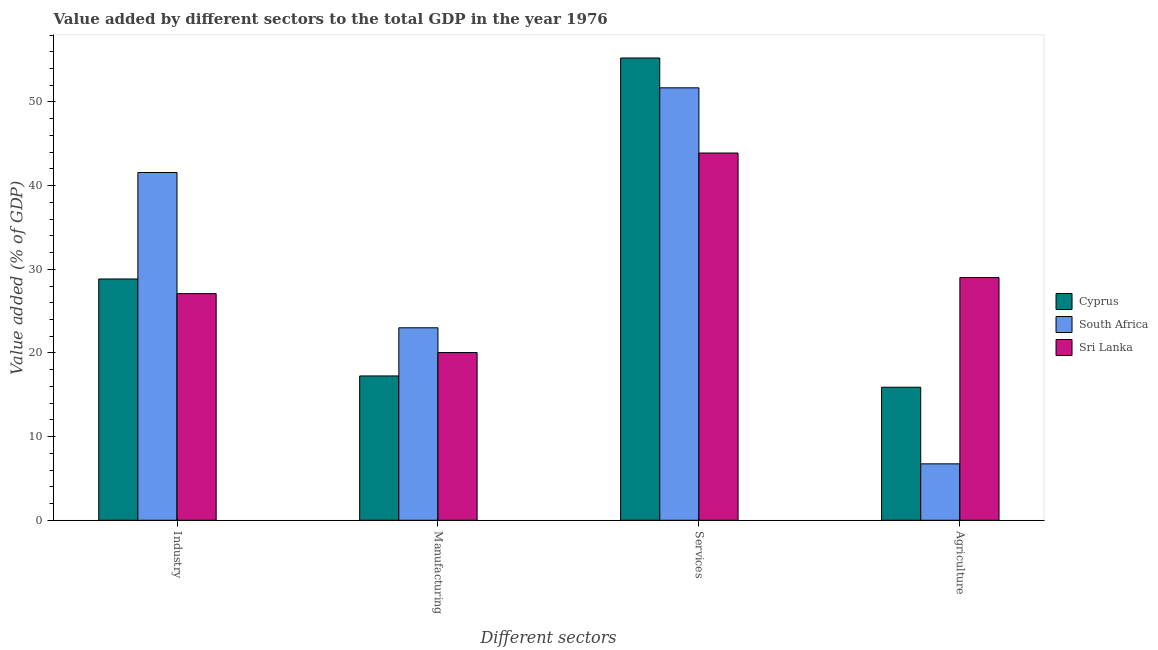Are the number of bars per tick equal to the number of legend labels?
Your response must be concise. Yes. How many bars are there on the 3rd tick from the left?
Ensure brevity in your answer.  3. How many bars are there on the 2nd tick from the right?
Your answer should be very brief. 3. What is the label of the 1st group of bars from the left?
Your answer should be compact. Industry. What is the value added by manufacturing sector in South Africa?
Make the answer very short. 23.01. Across all countries, what is the maximum value added by manufacturing sector?
Your answer should be very brief. 23.01. Across all countries, what is the minimum value added by services sector?
Offer a terse response. 43.9. In which country was the value added by industrial sector maximum?
Your answer should be compact. South Africa. In which country was the value added by manufacturing sector minimum?
Offer a very short reply. Cyprus. What is the total value added by agricultural sector in the graph?
Your answer should be compact. 51.66. What is the difference between the value added by services sector in Cyprus and that in South Africa?
Give a very brief answer. 3.57. What is the difference between the value added by agricultural sector in Cyprus and the value added by manufacturing sector in South Africa?
Provide a short and direct response. -7.1. What is the average value added by industrial sector per country?
Provide a short and direct response. 32.5. What is the difference between the value added by industrial sector and value added by services sector in Cyprus?
Keep it short and to the point. -26.42. What is the ratio of the value added by industrial sector in Sri Lanka to that in South Africa?
Offer a terse response. 0.65. What is the difference between the highest and the second highest value added by manufacturing sector?
Provide a succinct answer. 2.96. What is the difference between the highest and the lowest value added by industrial sector?
Your response must be concise. 14.48. What does the 2nd bar from the left in Agriculture represents?
Make the answer very short. South Africa. What does the 2nd bar from the right in Industry represents?
Provide a succinct answer. South Africa. Is it the case that in every country, the sum of the value added by industrial sector and value added by manufacturing sector is greater than the value added by services sector?
Provide a succinct answer. No. Are all the bars in the graph horizontal?
Offer a very short reply. No. Are the values on the major ticks of Y-axis written in scientific E-notation?
Make the answer very short. No. Where does the legend appear in the graph?
Your answer should be very brief. Center right. How many legend labels are there?
Offer a terse response. 3. How are the legend labels stacked?
Your response must be concise. Vertical. What is the title of the graph?
Your answer should be very brief. Value added by different sectors to the total GDP in the year 1976. What is the label or title of the X-axis?
Provide a short and direct response. Different sectors. What is the label or title of the Y-axis?
Offer a terse response. Value added (% of GDP). What is the Value added (% of GDP) in Cyprus in Industry?
Your response must be concise. 28.84. What is the Value added (% of GDP) of South Africa in Industry?
Keep it short and to the point. 41.57. What is the Value added (% of GDP) in Sri Lanka in Industry?
Keep it short and to the point. 27.09. What is the Value added (% of GDP) in Cyprus in Manufacturing?
Provide a short and direct response. 17.25. What is the Value added (% of GDP) of South Africa in Manufacturing?
Your answer should be very brief. 23.01. What is the Value added (% of GDP) in Sri Lanka in Manufacturing?
Give a very brief answer. 20.05. What is the Value added (% of GDP) of Cyprus in Services?
Give a very brief answer. 55.26. What is the Value added (% of GDP) of South Africa in Services?
Offer a very short reply. 51.69. What is the Value added (% of GDP) of Sri Lanka in Services?
Your answer should be very brief. 43.9. What is the Value added (% of GDP) of Cyprus in Agriculture?
Your answer should be compact. 15.9. What is the Value added (% of GDP) in South Africa in Agriculture?
Give a very brief answer. 6.74. What is the Value added (% of GDP) of Sri Lanka in Agriculture?
Your answer should be compact. 29.01. Across all Different sectors, what is the maximum Value added (% of GDP) of Cyprus?
Offer a very short reply. 55.26. Across all Different sectors, what is the maximum Value added (% of GDP) in South Africa?
Offer a very short reply. 51.69. Across all Different sectors, what is the maximum Value added (% of GDP) in Sri Lanka?
Provide a short and direct response. 43.9. Across all Different sectors, what is the minimum Value added (% of GDP) of Cyprus?
Your response must be concise. 15.9. Across all Different sectors, what is the minimum Value added (% of GDP) in South Africa?
Offer a very short reply. 6.74. Across all Different sectors, what is the minimum Value added (% of GDP) in Sri Lanka?
Keep it short and to the point. 20.05. What is the total Value added (% of GDP) in Cyprus in the graph?
Your answer should be compact. 117.25. What is the total Value added (% of GDP) of South Africa in the graph?
Provide a succinct answer. 123.01. What is the total Value added (% of GDP) of Sri Lanka in the graph?
Give a very brief answer. 120.05. What is the difference between the Value added (% of GDP) in Cyprus in Industry and that in Manufacturing?
Your response must be concise. 11.59. What is the difference between the Value added (% of GDP) in South Africa in Industry and that in Manufacturing?
Provide a short and direct response. 18.56. What is the difference between the Value added (% of GDP) in Sri Lanka in Industry and that in Manufacturing?
Ensure brevity in your answer.  7.04. What is the difference between the Value added (% of GDP) in Cyprus in Industry and that in Services?
Ensure brevity in your answer.  -26.42. What is the difference between the Value added (% of GDP) of South Africa in Industry and that in Services?
Give a very brief answer. -10.12. What is the difference between the Value added (% of GDP) of Sri Lanka in Industry and that in Services?
Make the answer very short. -16.81. What is the difference between the Value added (% of GDP) in Cyprus in Industry and that in Agriculture?
Provide a short and direct response. 12.94. What is the difference between the Value added (% of GDP) in South Africa in Industry and that in Agriculture?
Give a very brief answer. 34.82. What is the difference between the Value added (% of GDP) of Sri Lanka in Industry and that in Agriculture?
Provide a succinct answer. -1.92. What is the difference between the Value added (% of GDP) of Cyprus in Manufacturing and that in Services?
Offer a very short reply. -38.01. What is the difference between the Value added (% of GDP) of South Africa in Manufacturing and that in Services?
Make the answer very short. -28.68. What is the difference between the Value added (% of GDP) of Sri Lanka in Manufacturing and that in Services?
Your response must be concise. -23.85. What is the difference between the Value added (% of GDP) of Cyprus in Manufacturing and that in Agriculture?
Ensure brevity in your answer.  1.35. What is the difference between the Value added (% of GDP) in South Africa in Manufacturing and that in Agriculture?
Provide a succinct answer. 16.26. What is the difference between the Value added (% of GDP) of Sri Lanka in Manufacturing and that in Agriculture?
Ensure brevity in your answer.  -8.96. What is the difference between the Value added (% of GDP) of Cyprus in Services and that in Agriculture?
Offer a very short reply. 39.35. What is the difference between the Value added (% of GDP) in South Africa in Services and that in Agriculture?
Your answer should be compact. 44.95. What is the difference between the Value added (% of GDP) in Sri Lanka in Services and that in Agriculture?
Ensure brevity in your answer.  14.88. What is the difference between the Value added (% of GDP) in Cyprus in Industry and the Value added (% of GDP) in South Africa in Manufacturing?
Your answer should be very brief. 5.83. What is the difference between the Value added (% of GDP) of Cyprus in Industry and the Value added (% of GDP) of Sri Lanka in Manufacturing?
Your answer should be compact. 8.79. What is the difference between the Value added (% of GDP) of South Africa in Industry and the Value added (% of GDP) of Sri Lanka in Manufacturing?
Provide a short and direct response. 21.52. What is the difference between the Value added (% of GDP) of Cyprus in Industry and the Value added (% of GDP) of South Africa in Services?
Give a very brief answer. -22.85. What is the difference between the Value added (% of GDP) in Cyprus in Industry and the Value added (% of GDP) in Sri Lanka in Services?
Provide a succinct answer. -15.06. What is the difference between the Value added (% of GDP) in South Africa in Industry and the Value added (% of GDP) in Sri Lanka in Services?
Make the answer very short. -2.33. What is the difference between the Value added (% of GDP) of Cyprus in Industry and the Value added (% of GDP) of South Africa in Agriculture?
Your response must be concise. 22.1. What is the difference between the Value added (% of GDP) of Cyprus in Industry and the Value added (% of GDP) of Sri Lanka in Agriculture?
Offer a very short reply. -0.17. What is the difference between the Value added (% of GDP) of South Africa in Industry and the Value added (% of GDP) of Sri Lanka in Agriculture?
Give a very brief answer. 12.55. What is the difference between the Value added (% of GDP) in Cyprus in Manufacturing and the Value added (% of GDP) in South Africa in Services?
Give a very brief answer. -34.44. What is the difference between the Value added (% of GDP) of Cyprus in Manufacturing and the Value added (% of GDP) of Sri Lanka in Services?
Keep it short and to the point. -26.65. What is the difference between the Value added (% of GDP) of South Africa in Manufacturing and the Value added (% of GDP) of Sri Lanka in Services?
Provide a short and direct response. -20.89. What is the difference between the Value added (% of GDP) in Cyprus in Manufacturing and the Value added (% of GDP) in South Africa in Agriculture?
Provide a short and direct response. 10.51. What is the difference between the Value added (% of GDP) in Cyprus in Manufacturing and the Value added (% of GDP) in Sri Lanka in Agriculture?
Your answer should be compact. -11.76. What is the difference between the Value added (% of GDP) in South Africa in Manufacturing and the Value added (% of GDP) in Sri Lanka in Agriculture?
Your response must be concise. -6.01. What is the difference between the Value added (% of GDP) in Cyprus in Services and the Value added (% of GDP) in South Africa in Agriculture?
Your answer should be very brief. 48.51. What is the difference between the Value added (% of GDP) in Cyprus in Services and the Value added (% of GDP) in Sri Lanka in Agriculture?
Offer a very short reply. 26.24. What is the difference between the Value added (% of GDP) in South Africa in Services and the Value added (% of GDP) in Sri Lanka in Agriculture?
Keep it short and to the point. 22.68. What is the average Value added (% of GDP) of Cyprus per Different sectors?
Provide a succinct answer. 29.31. What is the average Value added (% of GDP) of South Africa per Different sectors?
Offer a very short reply. 30.75. What is the average Value added (% of GDP) of Sri Lanka per Different sectors?
Offer a terse response. 30.01. What is the difference between the Value added (% of GDP) in Cyprus and Value added (% of GDP) in South Africa in Industry?
Provide a short and direct response. -12.73. What is the difference between the Value added (% of GDP) in Cyprus and Value added (% of GDP) in Sri Lanka in Industry?
Ensure brevity in your answer.  1.75. What is the difference between the Value added (% of GDP) of South Africa and Value added (% of GDP) of Sri Lanka in Industry?
Provide a succinct answer. 14.48. What is the difference between the Value added (% of GDP) of Cyprus and Value added (% of GDP) of South Africa in Manufacturing?
Your answer should be very brief. -5.76. What is the difference between the Value added (% of GDP) of Cyprus and Value added (% of GDP) of Sri Lanka in Manufacturing?
Your answer should be very brief. -2.8. What is the difference between the Value added (% of GDP) of South Africa and Value added (% of GDP) of Sri Lanka in Manufacturing?
Give a very brief answer. 2.96. What is the difference between the Value added (% of GDP) of Cyprus and Value added (% of GDP) of South Africa in Services?
Ensure brevity in your answer.  3.57. What is the difference between the Value added (% of GDP) of Cyprus and Value added (% of GDP) of Sri Lanka in Services?
Provide a succinct answer. 11.36. What is the difference between the Value added (% of GDP) of South Africa and Value added (% of GDP) of Sri Lanka in Services?
Make the answer very short. 7.79. What is the difference between the Value added (% of GDP) of Cyprus and Value added (% of GDP) of South Africa in Agriculture?
Offer a very short reply. 9.16. What is the difference between the Value added (% of GDP) of Cyprus and Value added (% of GDP) of Sri Lanka in Agriculture?
Offer a very short reply. -13.11. What is the difference between the Value added (% of GDP) in South Africa and Value added (% of GDP) in Sri Lanka in Agriculture?
Your answer should be very brief. -22.27. What is the ratio of the Value added (% of GDP) of Cyprus in Industry to that in Manufacturing?
Make the answer very short. 1.67. What is the ratio of the Value added (% of GDP) of South Africa in Industry to that in Manufacturing?
Your response must be concise. 1.81. What is the ratio of the Value added (% of GDP) in Sri Lanka in Industry to that in Manufacturing?
Your answer should be compact. 1.35. What is the ratio of the Value added (% of GDP) in Cyprus in Industry to that in Services?
Provide a succinct answer. 0.52. What is the ratio of the Value added (% of GDP) of South Africa in Industry to that in Services?
Offer a very short reply. 0.8. What is the ratio of the Value added (% of GDP) of Sri Lanka in Industry to that in Services?
Your response must be concise. 0.62. What is the ratio of the Value added (% of GDP) of Cyprus in Industry to that in Agriculture?
Ensure brevity in your answer.  1.81. What is the ratio of the Value added (% of GDP) of South Africa in Industry to that in Agriculture?
Your answer should be very brief. 6.16. What is the ratio of the Value added (% of GDP) in Sri Lanka in Industry to that in Agriculture?
Provide a succinct answer. 0.93. What is the ratio of the Value added (% of GDP) of Cyprus in Manufacturing to that in Services?
Provide a short and direct response. 0.31. What is the ratio of the Value added (% of GDP) of South Africa in Manufacturing to that in Services?
Provide a succinct answer. 0.45. What is the ratio of the Value added (% of GDP) of Sri Lanka in Manufacturing to that in Services?
Provide a short and direct response. 0.46. What is the ratio of the Value added (% of GDP) in Cyprus in Manufacturing to that in Agriculture?
Offer a terse response. 1.08. What is the ratio of the Value added (% of GDP) in South Africa in Manufacturing to that in Agriculture?
Provide a succinct answer. 3.41. What is the ratio of the Value added (% of GDP) in Sri Lanka in Manufacturing to that in Agriculture?
Make the answer very short. 0.69. What is the ratio of the Value added (% of GDP) in Cyprus in Services to that in Agriculture?
Your response must be concise. 3.47. What is the ratio of the Value added (% of GDP) in South Africa in Services to that in Agriculture?
Keep it short and to the point. 7.66. What is the ratio of the Value added (% of GDP) in Sri Lanka in Services to that in Agriculture?
Offer a terse response. 1.51. What is the difference between the highest and the second highest Value added (% of GDP) in Cyprus?
Give a very brief answer. 26.42. What is the difference between the highest and the second highest Value added (% of GDP) of South Africa?
Give a very brief answer. 10.12. What is the difference between the highest and the second highest Value added (% of GDP) in Sri Lanka?
Your answer should be very brief. 14.88. What is the difference between the highest and the lowest Value added (% of GDP) in Cyprus?
Make the answer very short. 39.35. What is the difference between the highest and the lowest Value added (% of GDP) in South Africa?
Make the answer very short. 44.95. What is the difference between the highest and the lowest Value added (% of GDP) in Sri Lanka?
Your answer should be very brief. 23.85. 